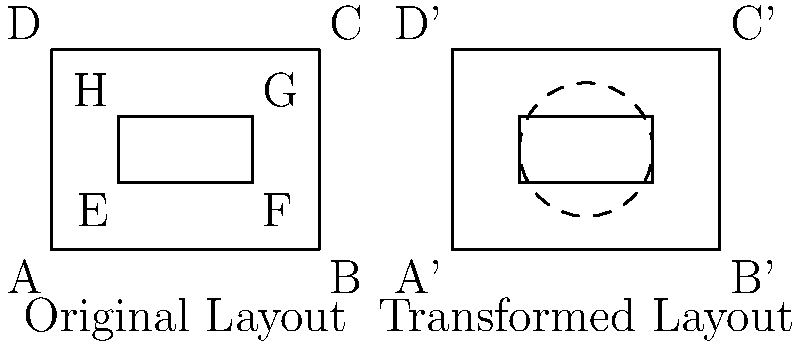A factory floor layout needs to be transformed to optimize energy flow. The original layout is represented by rectangle ABCD with an internal equipment area EFGH. To reduce waste, the layout must be shifted 6 units to the right and rotated 90° clockwise around the center of the new position of EFGH. What is the area of the circular region affected by this rotation? To solve this problem, we'll follow these steps:

1) First, we shift the entire layout 6 units to the right. This doesn't change the dimensions or area of any part of the layout.

2) After shifting, we need to find the center of the new position of EFGH. 
   - The width of EFGH is 2 units (from 1 to 3 on the x-axis).
   - The height of EFGH is 1 unit (from 1 to 2 on the y-axis).
   - The center is at the midpoint of EFGH, which is (2, 1.5) in the original layout.
   - After shifting 6 units right, the center is at (8, 1.5).

3) The rotation will be around this point (8, 1.5).

4) The question asks for the area of the circular region affected by the rotation. This is equivalent to finding the area of a circle whose radius is the distance from the rotation center to the farthest point of the layout.

5) The farthest points from the center of EFGH are the corners of ABCD. We can calculate this distance using the Pythagorean theorem:
   - Horizontal distance from center to corner: 2 units
   - Vertical distance from center to corner: 1.5 units
   - Distance = $\sqrt{2^2 + 1.5^2} = \sqrt{4 + 2.25} = \sqrt{6.25} = 2.5$ units

6) Now that we have the radius, we can calculate the area of the circle:
   Area = $\pi r^2 = \pi (2.5)^2 = 6.25\pi$ square units

Therefore, the area of the circular region affected by the rotation is $6.25\pi$ square units.
Answer: $6.25\pi$ square units 